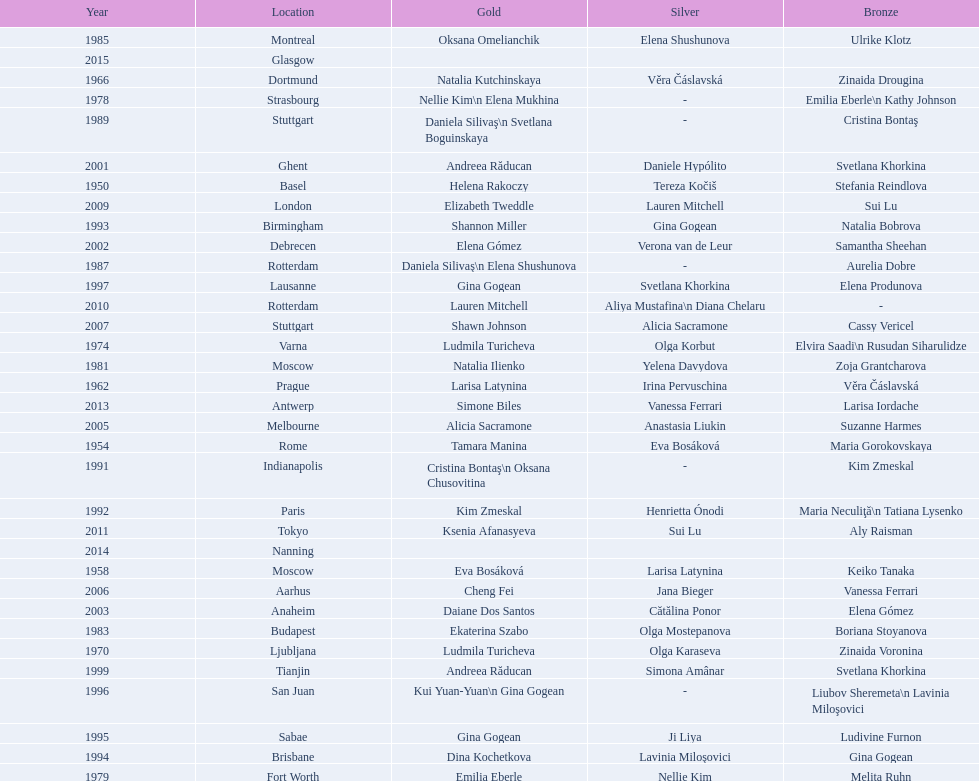How many times was the location in the united states? 3. 